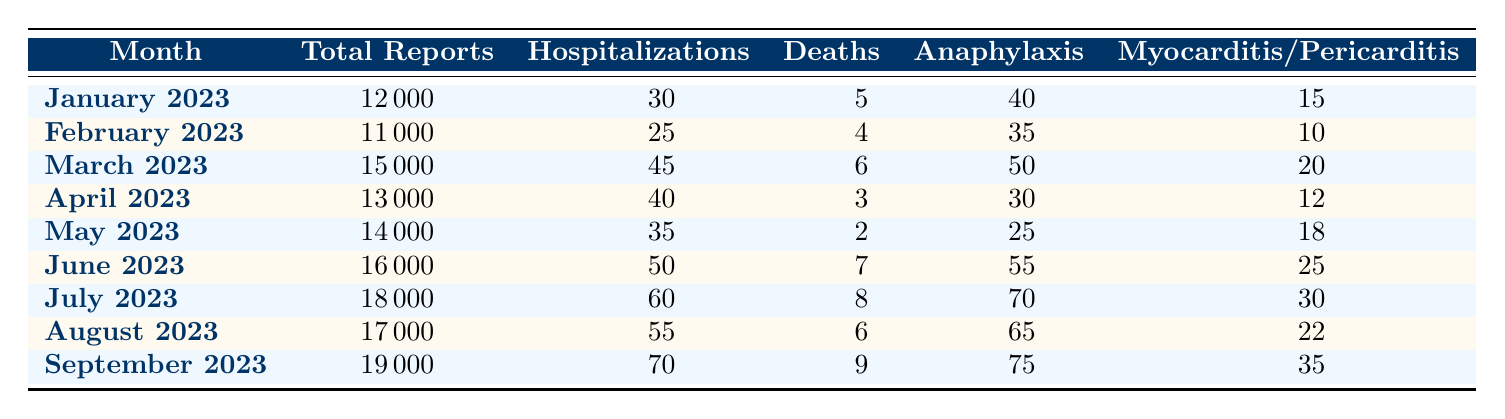What is the total number of adverse event reports in March 2023? The total number of adverse event reports for March 2023 is directly listed in the table under the "Total Reports" column. In March 2023, this value is 15000.
Answer: 15000 What month had the highest number of deaths reported? By inspecting the "Deaths" column across all months, September 2023 has the highest reported deaths at 9.
Answer: September 2023 What is the average number of hospitalizations from January to April 2023? To find the average hospitalizations from January to April 2023, we add the hospitalizations for each month (30 + 25 + 45 + 40 = 140) and then divide by the number of months (4). This results in an average of 140 / 4 = 35.
Answer: 35 Was there an increase in reports from July 2023 to September 2023? We compare the total reports for July 2023 (18000) with September 2023 (19000). Since September has more reports than July, we can conclude that there was indeed an increase in reports.
Answer: Yes What is the total number of myocardiatis/pericarditis cases reported from June to September 2023? We sum the number of myocarditis/pericarditis cases from June (25), July (30), August (22), and September (35) for the total: 25 + 30 + 22 + 35 = 112.
Answer: 112 In which month was the lowest number of anaphylaxis cases reported? By scanning the "Anaphylaxis" column, we note that February 2023 has the lowest count with 35 cases compared to other months.
Answer: February 2023 What was the percentage increase in total adverse event reports from January to June 2023? To find the percentage increase, we take the total reports in June (16000) and subtract the reports in January (12000), giving us an increase of 4000. To find the percentage, we divide the increase (4000) by the initial number (12000) and multiply by 100: (4000 / 12000) * 100 = 33.33%.
Answer: 33.33% How many months reported at least 60 hospitalizations? Reviewing the "Hospitalizations" column, the months of June, July, and September all report 60 or more hospitalizations (50, 60, and 70 respectively). This totals 3 months.
Answer: 3 Was there a month without any reported deaths? By evaluating the "Deaths" column, we see that every month from January to September has reports of deaths, therefore there was no month without any reported deaths.
Answer: No 